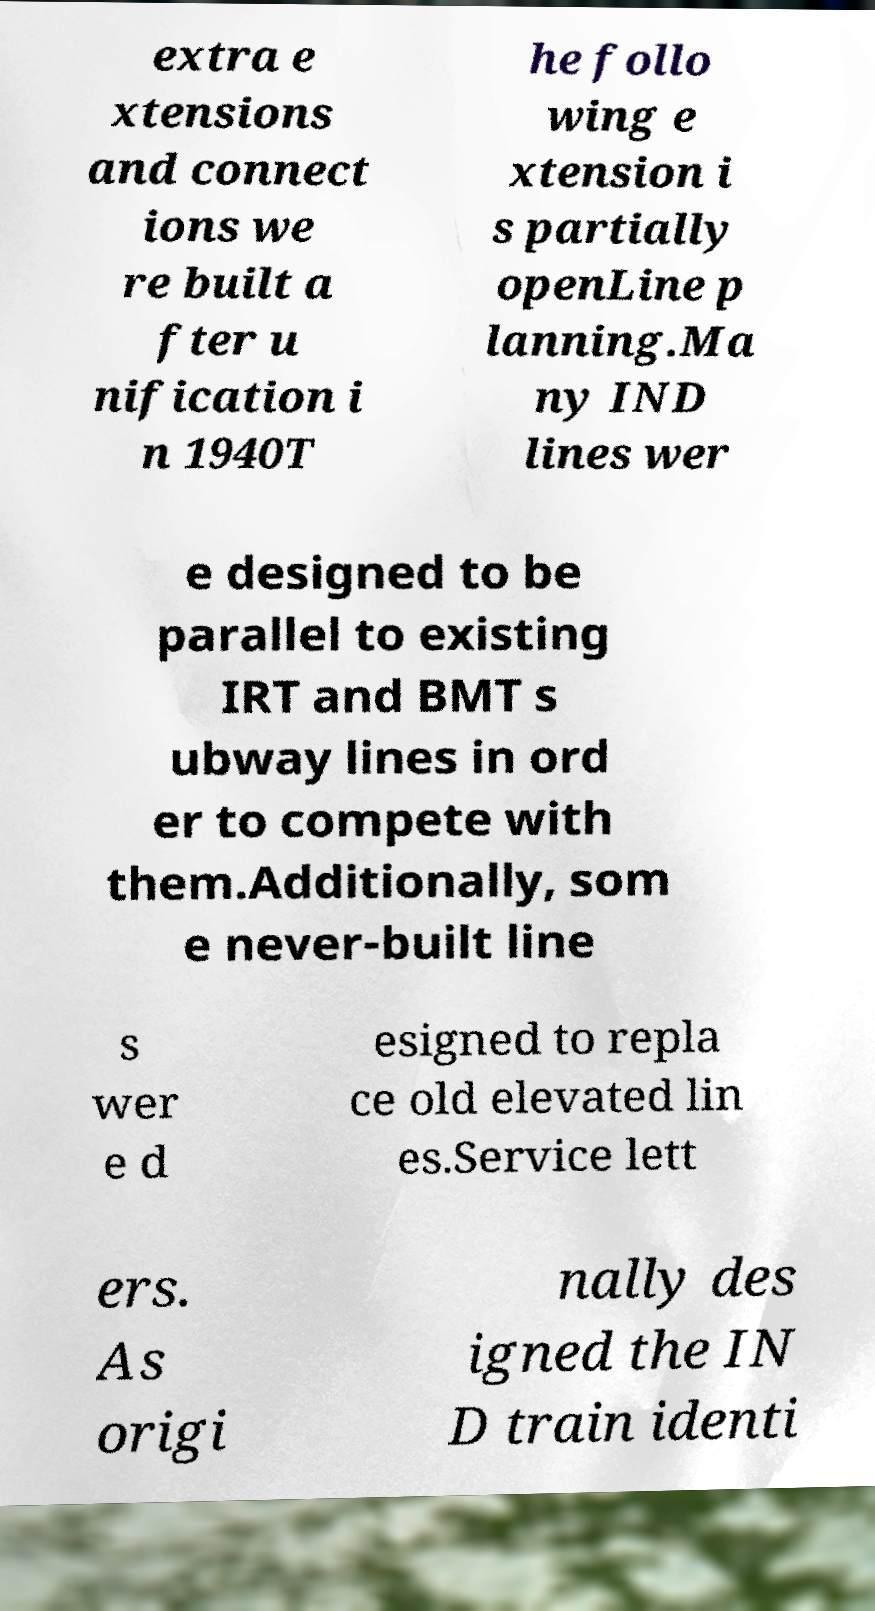Can you read and provide the text displayed in the image?This photo seems to have some interesting text. Can you extract and type it out for me? extra e xtensions and connect ions we re built a fter u nification i n 1940T he follo wing e xtension i s partially openLine p lanning.Ma ny IND lines wer e designed to be parallel to existing IRT and BMT s ubway lines in ord er to compete with them.Additionally, som e never-built line s wer e d esigned to repla ce old elevated lin es.Service lett ers. As origi nally des igned the IN D train identi 